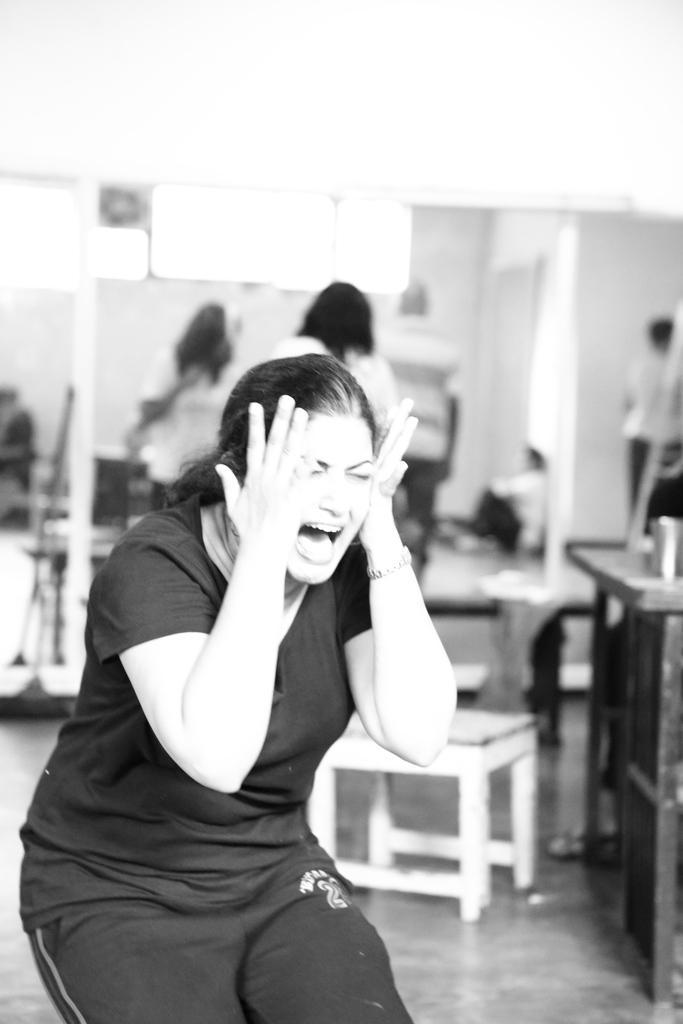Can you describe this image briefly? In this black and white picture a person is wearing a shirt. Beside her there is a chair. Behind her there are few persons standing. A person is sitting on the floor. 